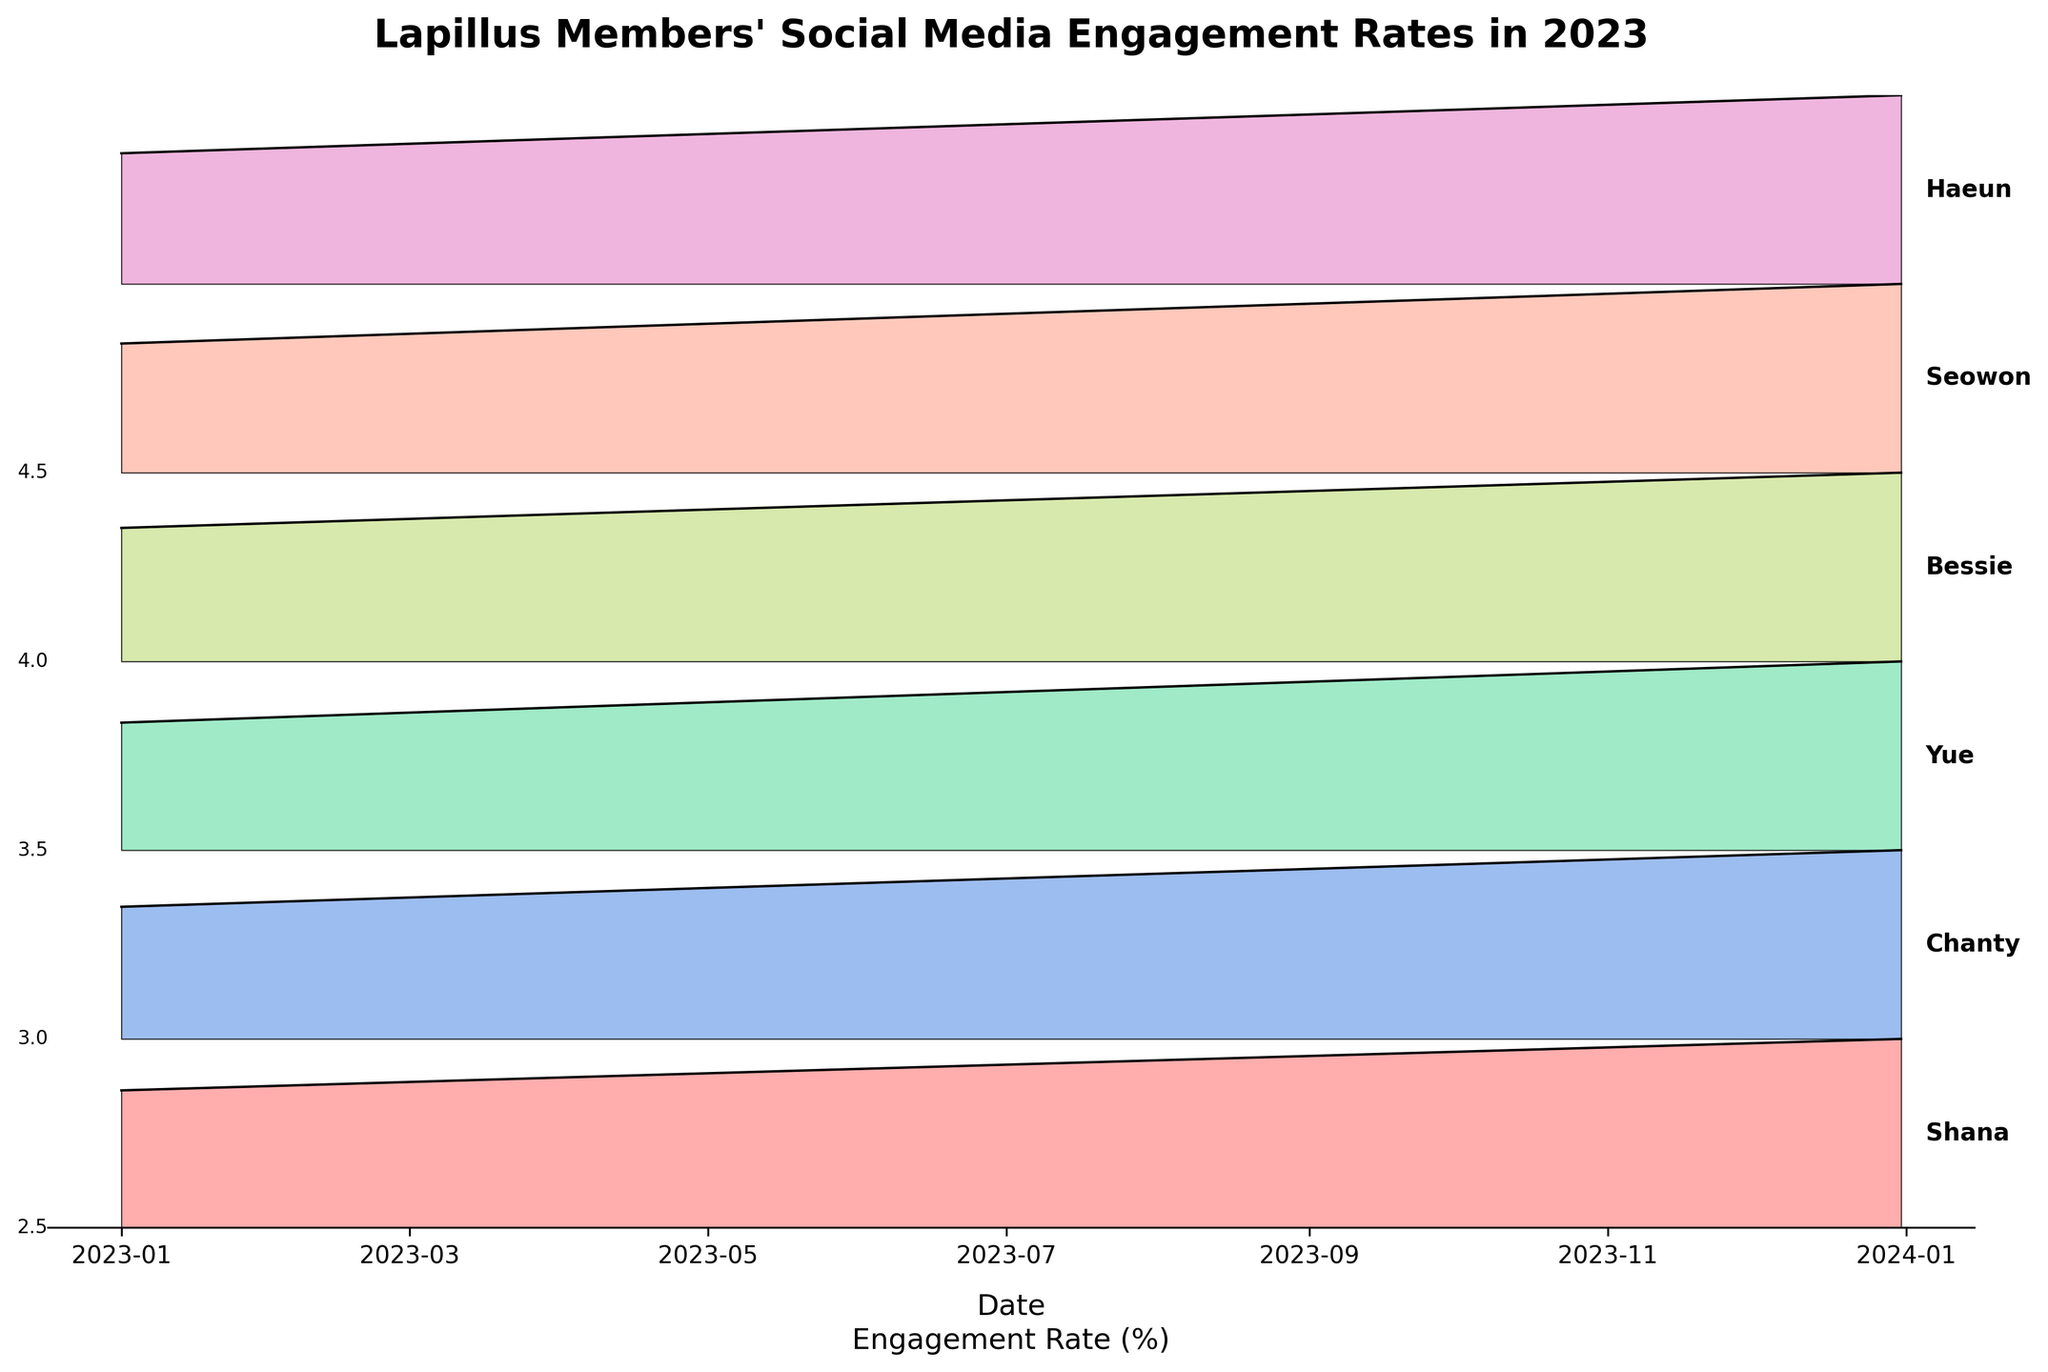What is the title of the plot? The title is usually displayed at the top of a plot. Here, the title given at the top of the plot is "Lapillus Members' Social Media Engagement Rates in 2023".
Answer: "Lapillus Members' Social Media Engagement Rates in 2023" Which member had the highest engagement rate on 2023-12-31? By looking at the tallest peak on 2023-12-31 along the x-axis, the tallest peak corresponds to the "Shana" ridge on the plot.
Answer: Shana How does Shana's engagement rate in October compare to December? By comparing the height of Shana's ridges on the x-axis for October and December, you can see that her engagement rate is higher in December (4.4%) than in October (4.1%).
Answer: Higher in December Which member shows the most significant increase in engagement rate from January to December? To determine the significant increase, compare the difference in heights between January and December for each member's ridges. Shana's engagement rate increased from 3.2% in January to 4.4% in December.
Answer: Shana What is the general trend of social media engagement rates among all members? Observing the plot, each member's ridge height increases over the year, indicating a general upward trend in their social media engagement rates.
Answer: Increasing Which month saw the least variation in engagement rates among members? Variation can be judged by the range between the highest and lowest peaks. In April, for instance, the engagement rates range between 2.8% (Yue) and 3.5% (Shana), showing the least spread.
Answer: April How does Yue's engagement rate change from April to July? The height of Yue's ridge in April is lower than in July. Specifically, it increases from 2.8% in April to 3.1% in July.
Answer: It increases What can be inferred from Bessie's engagement rate throughout the year? Examining Bessie's ridges month-by-month, you can observe a consistent increase from 2.9% in January to 4.1% in December.
Answer: Consistent increase Is there a member whose engagement rate remains below 4.0% throughout the year? By looking at the ridges and their peak heights, Yue's engagement rate does not reach above 4.0% at any point in the plot.
Answer: Yue 